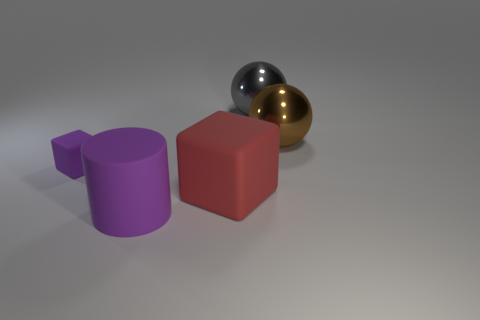There is a large cube to the left of the metal sphere to the left of the brown metal thing; what is its material?
Your response must be concise. Rubber. There is a cylinder; does it have the same size as the cube to the left of the large red cube?
Give a very brief answer. No. Are there any rubber balls of the same color as the large rubber block?
Ensure brevity in your answer.  No. How many tiny things are either red matte objects or purple objects?
Make the answer very short. 1. How many big yellow things are there?
Offer a terse response. 0. What is the material of the block that is to the right of the big purple rubber object?
Your response must be concise. Rubber. Are there any large gray shiny spheres in front of the brown ball?
Your answer should be very brief. No. Do the gray thing and the purple cylinder have the same size?
Ensure brevity in your answer.  Yes. How many brown things are the same material as the gray sphere?
Provide a succinct answer. 1. How big is the cube that is behind the rubber block that is to the right of the matte cylinder?
Provide a short and direct response. Small. 